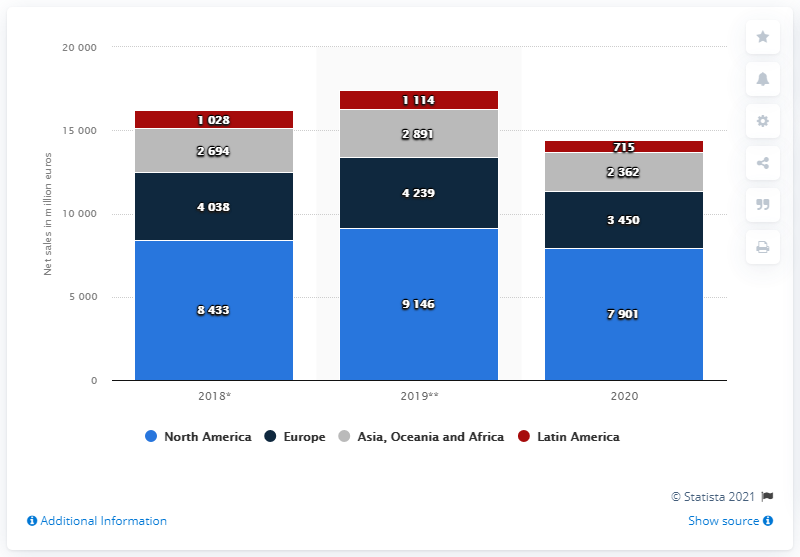Indicate a few pertinent items in this graphic. EssilorLuxottica's North America segment reported global net sales of 7,901 in 2020. 